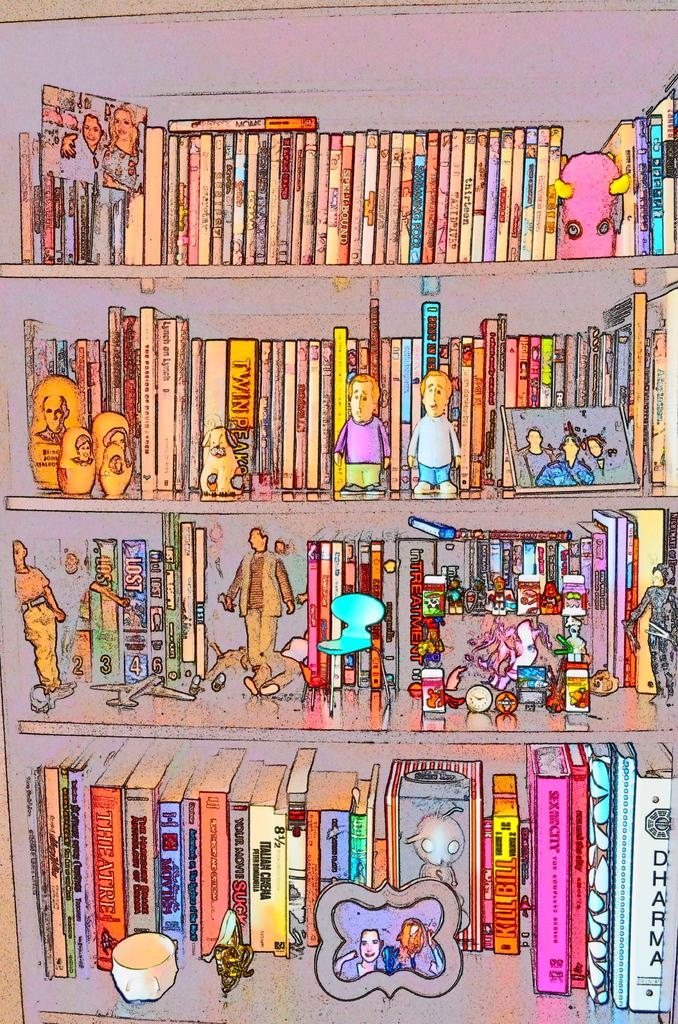<image>
Write a terse but informative summary of the picture. An illustrated book shelf with a book named DHARMA on the bottom shelf. 